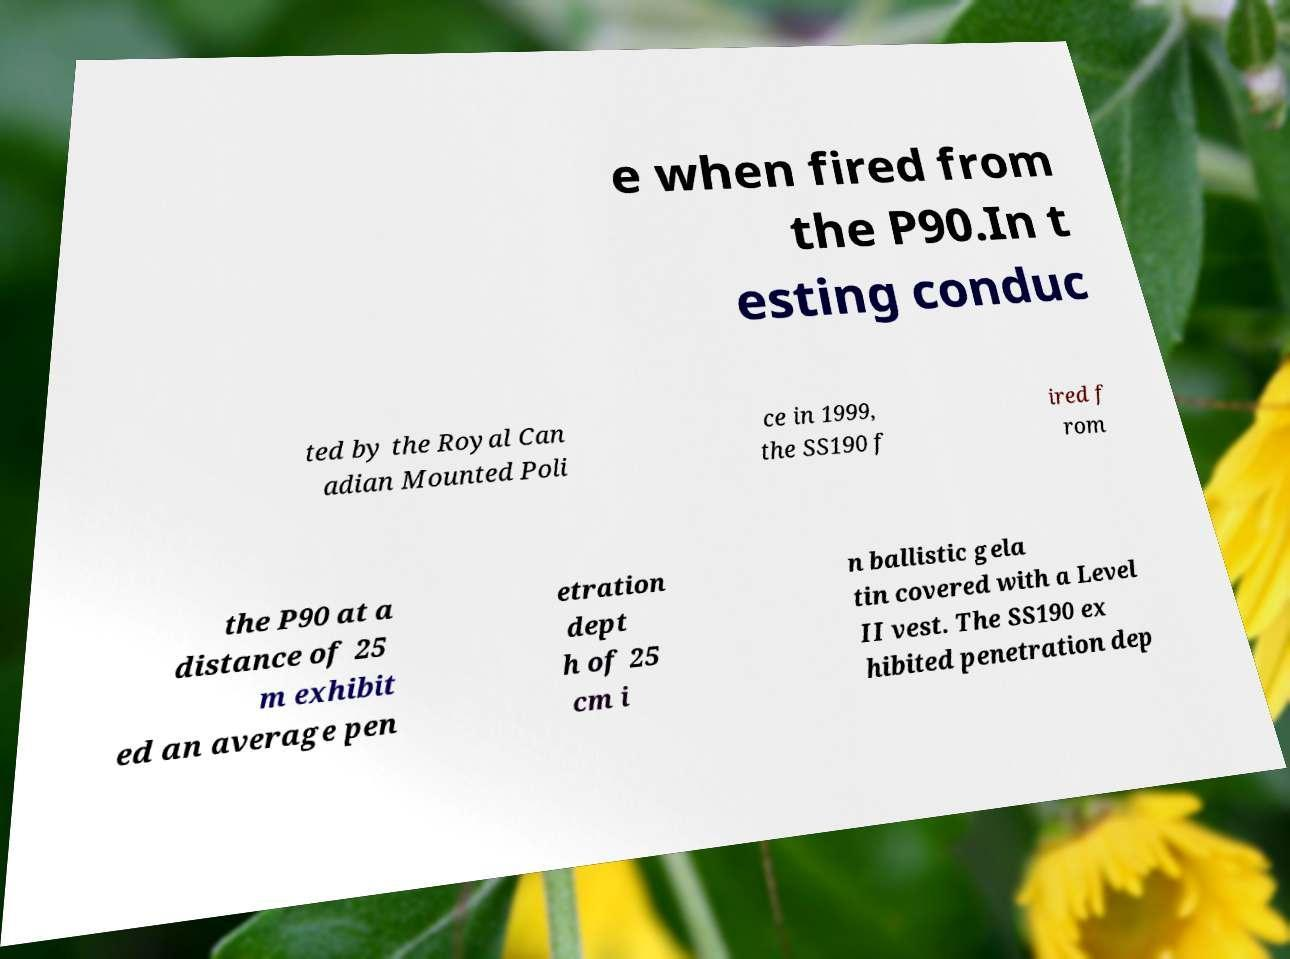I need the written content from this picture converted into text. Can you do that? e when fired from the P90.In t esting conduc ted by the Royal Can adian Mounted Poli ce in 1999, the SS190 f ired f rom the P90 at a distance of 25 m exhibit ed an average pen etration dept h of 25 cm i n ballistic gela tin covered with a Level II vest. The SS190 ex hibited penetration dep 